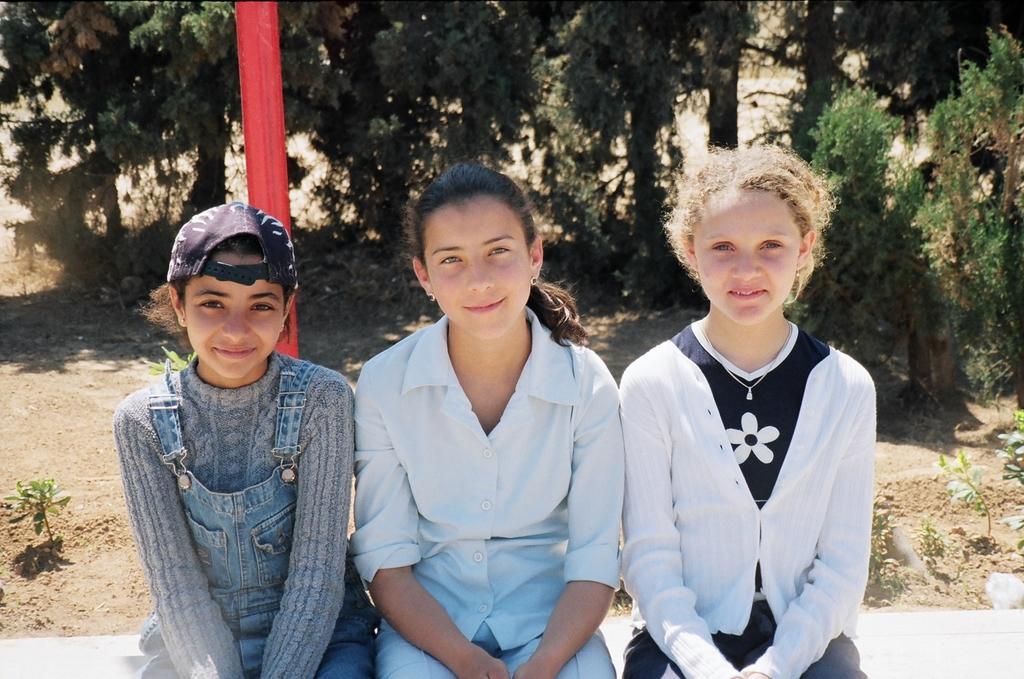Describe this image in one or two sentences. There are three girls sitting here. The girl on the right side is wearing a white colour jacket and the girl in the middle is wearing a white shirt and the girl on the left side is wearing a dress and she is wearing a cap on her head. These three girls are smiling. The girl in the left side, beside her there is a plant. And their, behind the three of these girls there are some, there is some open space. And in the background we can observe some trees and a red colour pole. 